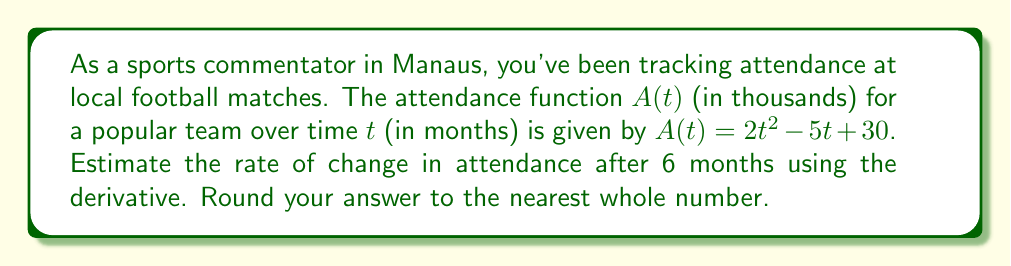Help me with this question. To solve this problem, we'll follow these steps:

1) First, we need to find the derivative of the attendance function $A(t)$. 
   $A(t) = 2t^2 - 5t + 30$
   $A'(t) = 4t - 5$

2) The derivative $A'(t)$ represents the rate of change of attendance with respect to time.

3) We're asked to estimate the rate of change after 6 months, so we need to evaluate $A'(6)$:
   $A'(6) = 4(6) - 5$
   $A'(6) = 24 - 5 = 19$

4) The result, 19, represents the rate of change in thousands of attendees per month.

5) Rounding to the nearest whole number, we get 19.

Therefore, after 6 months, the attendance is estimated to be increasing at a rate of approximately 19,000 people per month.
Answer: 19 thousand per month 